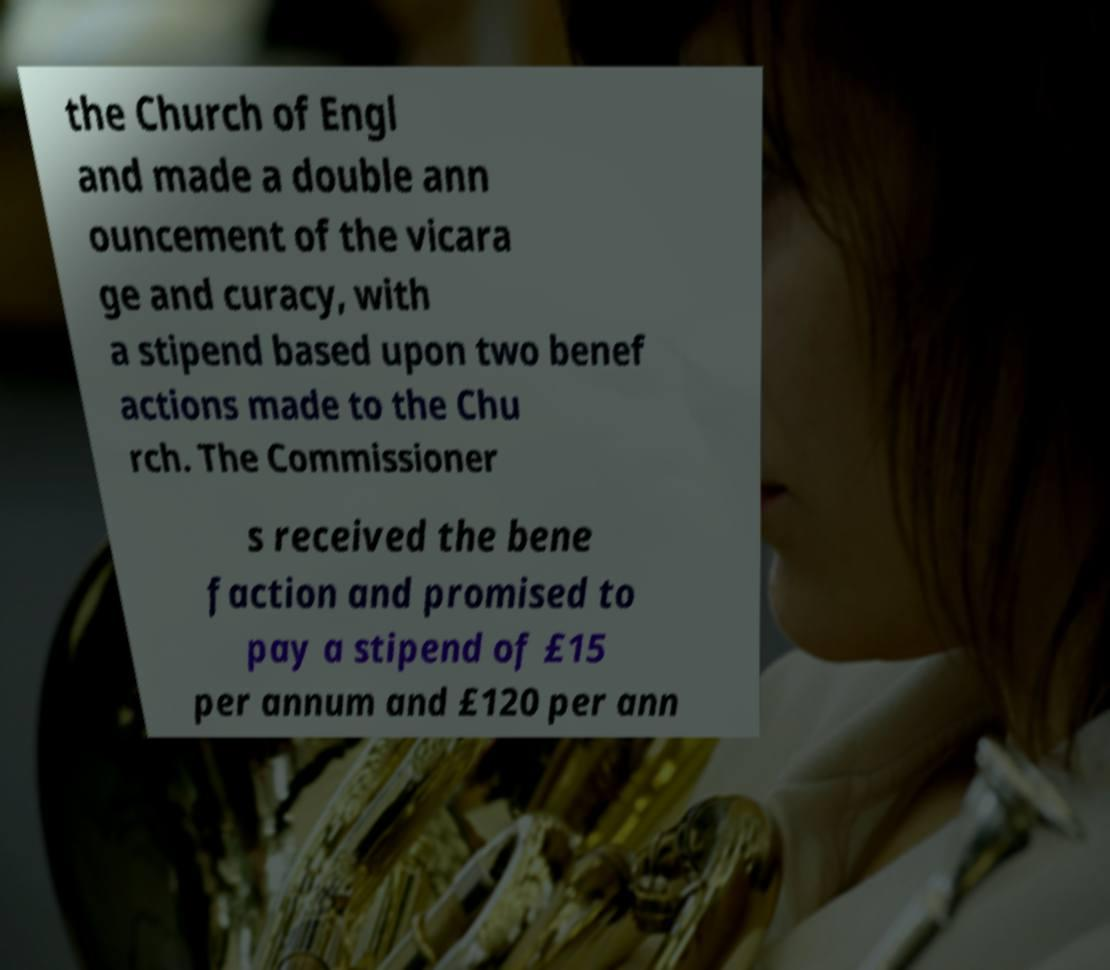I need the written content from this picture converted into text. Can you do that? the Church of Engl and made a double ann ouncement of the vicara ge and curacy, with a stipend based upon two benef actions made to the Chu rch. The Commissioner s received the bene faction and promised to pay a stipend of £15 per annum and £120 per ann 